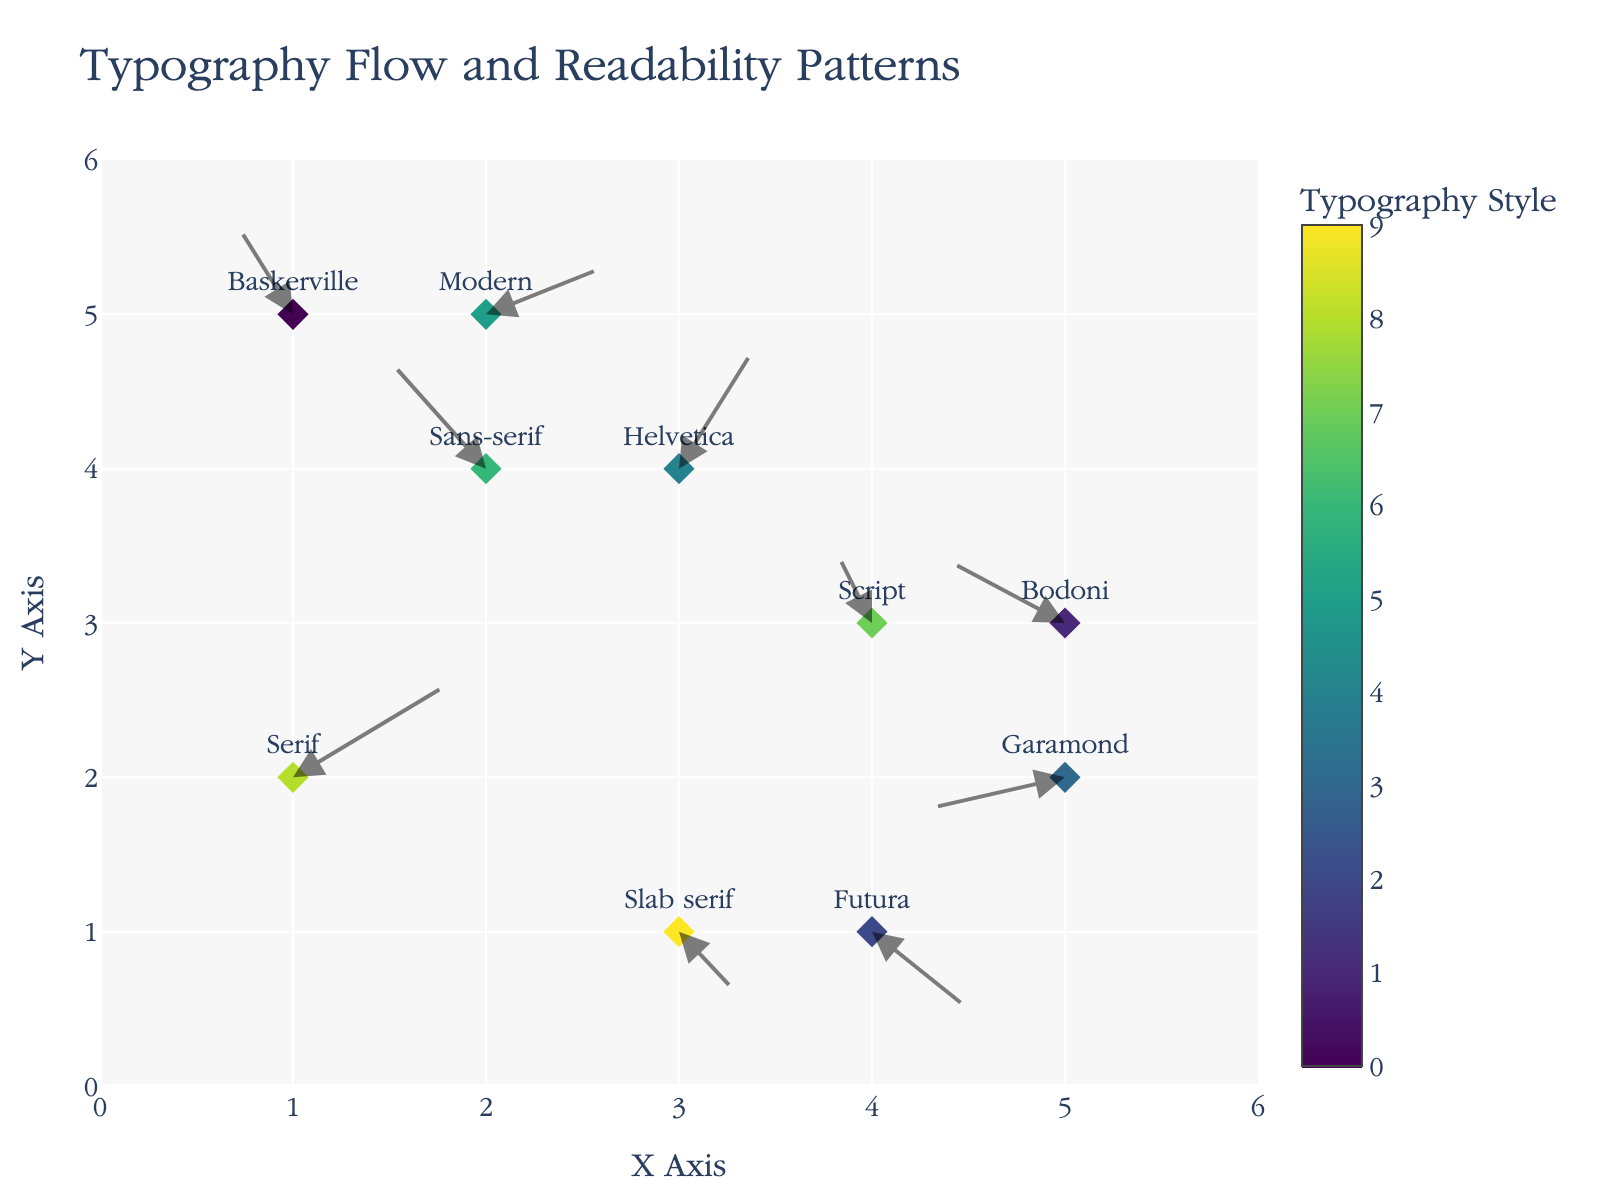what is the title of the figure? The title of the figure is located at the top center and it visually displays the text.
Answer: Typography Flow and Readability Patterns What are the x-axis and y-axis labels? The x-axis and y-axis labels are located at the bottom and left sides of the figure, respectively. The labels are visible.
Answer: X Axis and Y Axis How many data points are there in the figure? Each data point is represented by a diamond marker on the plot. Count the number of diamond markers in the figure to find the answer.
Answer: 10 Which typography style has the highest y-coordinate? Look for the highest y-coordinate (the point farthest up on the vertical axis) and identify the typography style associated with it.
Answer: Modern What is the color associated with the typography style 'Futura'? Locate 'Futura' on the plot and observe the color of its diamond marker, which represents the typography style.
Answer: Yellowish (based on Viridis color scale) Which typography style changes direction more horizontally compared to vertically? Compare the length of the horizontal (u) and vertical (v) arrow components for each typography style to determine which has a greater horizontal movement.
Answer: Bodoni Compare the flow directions of 'Serif' and 'Sans-serif'. Which one moves more to the right? Check the arrow direction for both 'Serif' and 'Sans-serif'. Observe their horizontal movement by comparing the lengths of their arrows in the right direction (positive x-axis).
Answer: Serif How does the direction of 'Garamond' compare with 'Helvetica' in terms of vertical movement? Evaluate the vertical arrow components (v) for 'Garamond' and 'Helvetica'. Compare their lengths to see which has greater vertical movement.
Answer: Helvetica has greater upward movement Which typography style has the most downward movement? Identify the typography style with the largest negative vertical component (v) by examining the arrows pointing down.
Answer: Slab serif Calculate the average x-coordinate for the typography styles that have a positive vertical movement. Find the typography styles with positive vertical movement (positive v values), sum their x-coordinates, and divide by the number of these styles.
Answer: (1 + 2 + 4 + 2 + 3) / 5 = 2.4 